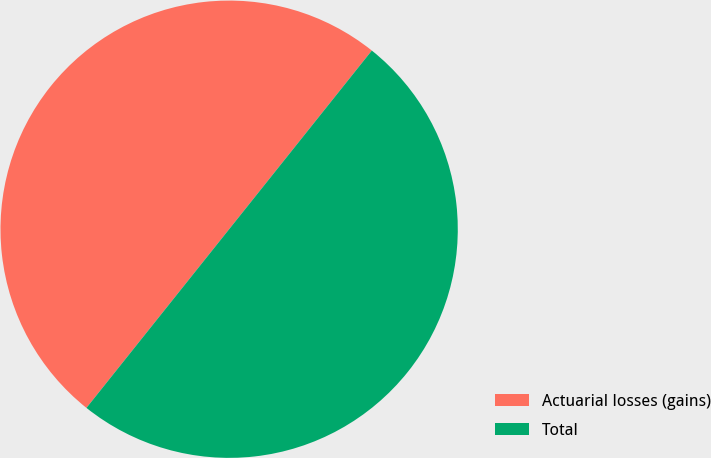Convert chart to OTSL. <chart><loc_0><loc_0><loc_500><loc_500><pie_chart><fcel>Actuarial losses (gains)<fcel>Total<nl><fcel>50.0%<fcel>50.0%<nl></chart> 